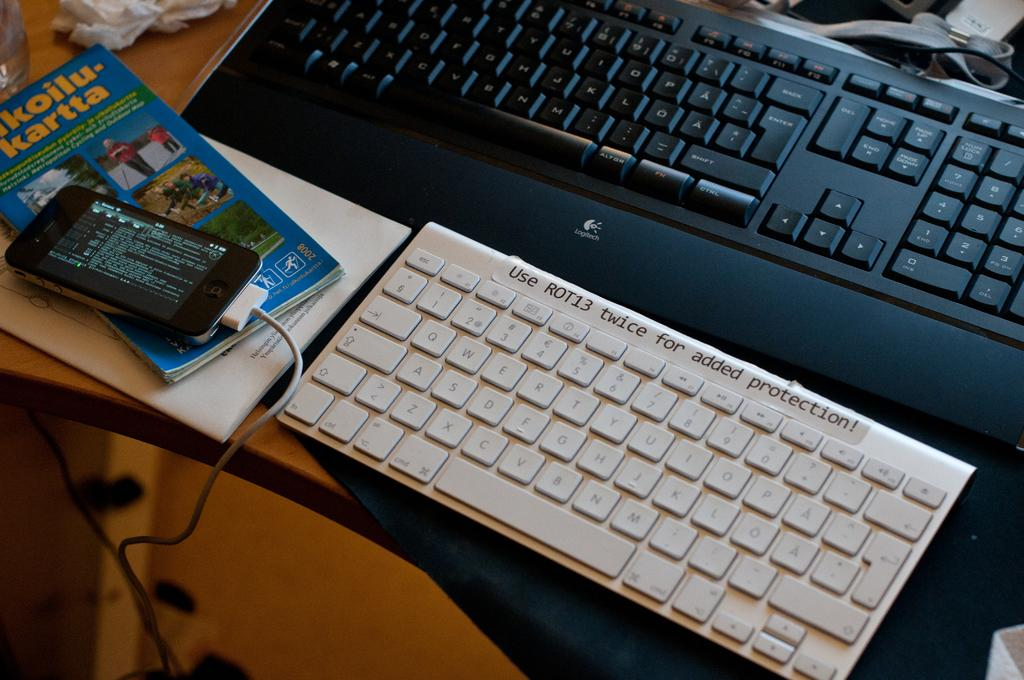What is the color of the keywords in the image? The keywords in the image are in black and white color. What can be seen on the left side of the image? There is a mobile, books, and a glass on the left side of the image. What is the color of the table in the image? The table is brown in color. Where is the suit stored in the image? A: There is no suit present in the image. What type of memory is depicted in the image? There is no memory depicted in the image; it features keywords in black and white color, a mobile, books, a glass, and a brown table. 